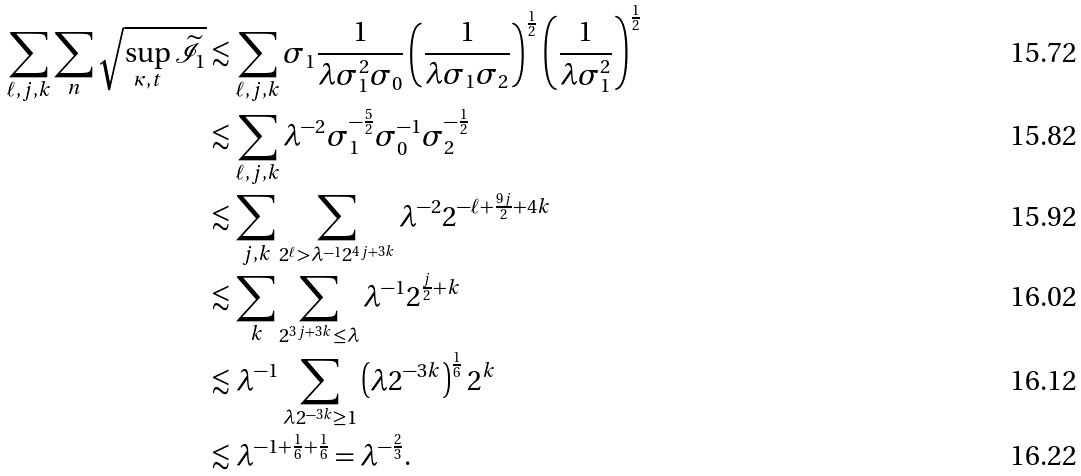<formula> <loc_0><loc_0><loc_500><loc_500>\sum _ { \ell , j , k } \sum _ { n } \sqrt { \sup _ { \kappa , t } \widetilde { \mathcal { I } } _ { 1 } } & \lesssim \sum _ { \ell , j , k } \sigma _ { 1 } \frac { 1 } { \lambda \sigma _ { 1 } ^ { 2 } \sigma _ { 0 } } \left ( \frac { 1 } { \lambda \sigma _ { 1 } \sigma _ { 2 } } \right ) ^ { \frac { 1 } { 2 } } \left ( \frac { 1 } { \lambda \sigma _ { 1 } ^ { 2 } } \right ) ^ { \frac { 1 } { 2 } } \\ & \lesssim \sum _ { \ell , j , k } \lambda ^ { - 2 } \sigma _ { 1 } ^ { - \frac { 5 } { 2 } } \sigma _ { 0 } ^ { - 1 } \sigma _ { 2 } ^ { - \frac { 1 } { 2 } } \\ & \lesssim \sum _ { j , k } \sum _ { 2 ^ { \ell } > \lambda ^ { - 1 } 2 ^ { 4 j + 3 k } } \lambda ^ { - 2 } 2 ^ { - \ell + \frac { 9 j } { 2 } + 4 k } \\ & \lesssim \sum _ { k } \sum _ { 2 ^ { 3 j + 3 k } \leq \lambda } \lambda ^ { - 1 } 2 ^ { \frac { j } { 2 } + k } \\ & \lesssim \lambda ^ { - 1 } \sum _ { \lambda 2 ^ { - 3 k } \geq 1 } \left ( \lambda 2 ^ { - 3 k } \right ) ^ { \frac { 1 } { 6 } } 2 ^ { k } \\ & \lesssim \lambda ^ { - 1 + \frac { 1 } { 6 } + \frac { 1 } { 6 } } = \lambda ^ { - \frac { 2 } { 3 } } .</formula> 